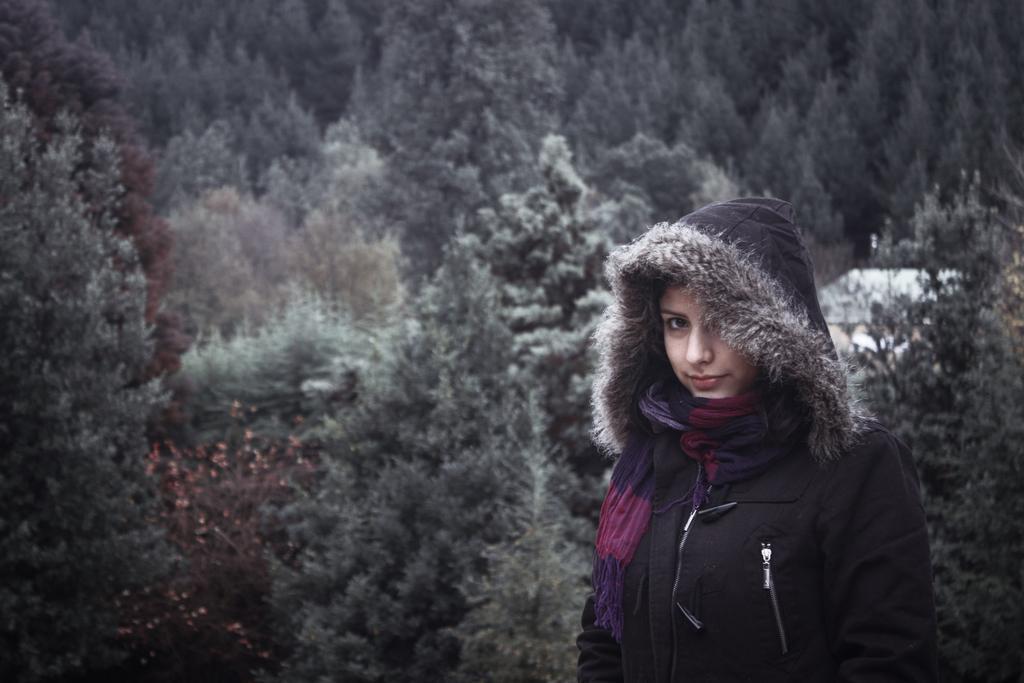In one or two sentences, can you explain what this image depicts? In this image in the foreground there is one woman who is standing, and in the background there are some trees. 